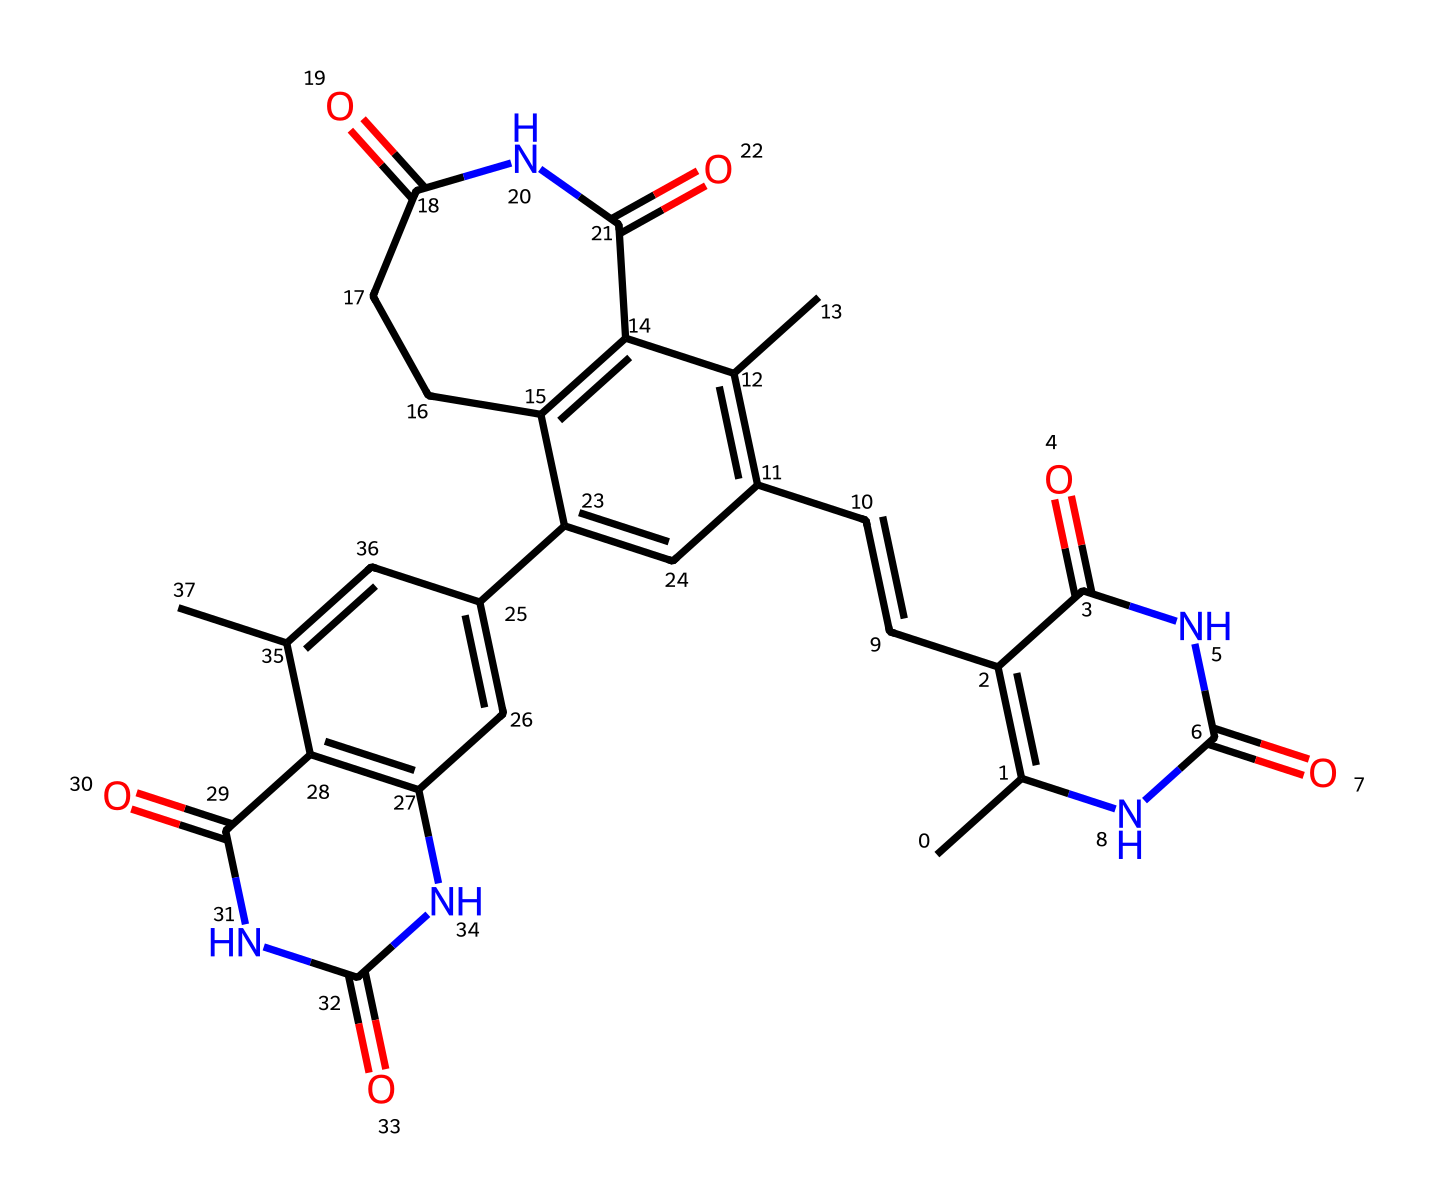What is the molecular formula of bilirubin based on its structure? By analyzing the chemical structure represented by the SMILES string, we can tally all the carbon (C), hydrogen (H), nitrogen (N), and oxygen (O) atoms to derive the molecular formula. The counting yields a total of 33 carbons, 36 hydrogens, 4 nitrogens, and 6 oxygens.
Answer: C33H36N4O6 How many rings are present in the structure of bilirubin? Upon reviewing the chemical structure, we can identify distinct cyclic structures (rings) in the compound. There are four rings observed in the structure, signifying a polycyclic character typical of bilirubin.
Answer: 4 Which functional groups are present in bilirubin? By examining the bonds and atom types, we note the occurrence of amide (N-C=O) and carbonyl (C=O) groups evident in the structure. These functional groups are critical for the reactivity of bilirubin.
Answer: amide, carbonyl What type of light is effective for photodegrading bilirubin? Understanding the nature of bilirubin and its photoreactivity leads us to conclude that ultraviolet (UV) light is typically effective for its photodegradation in treating jaundice, as it activates the photoreactive properties.
Answer: UV light What role does bilirubin play in infant jaundice? Analyzing the properties of bilirubin highlights its involvement in the breakdown of hemoglobin; elevated levels result in jaundice, as the liver of infants often struggles to process bilirubin effectively.
Answer: bilirubin buildup What happens to bilirubin after photodegradation? Evaluating the photodegradation process indicates that bilirubin is converted into water-soluble isomers that can be excreted from the body. This transformation is essential for treating jaundice effectively.
Answer: water-soluble isomers 